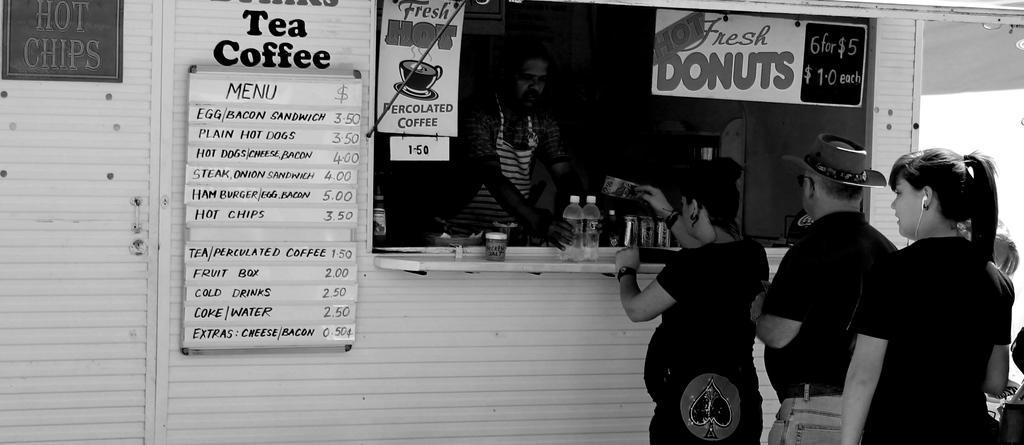Could you give a brief overview of what you see in this image? This picture consists of shop , in front of shop I can see few person and in the shop I can see person and glass and hoarding board and menu card attached to the wall of the shop. 